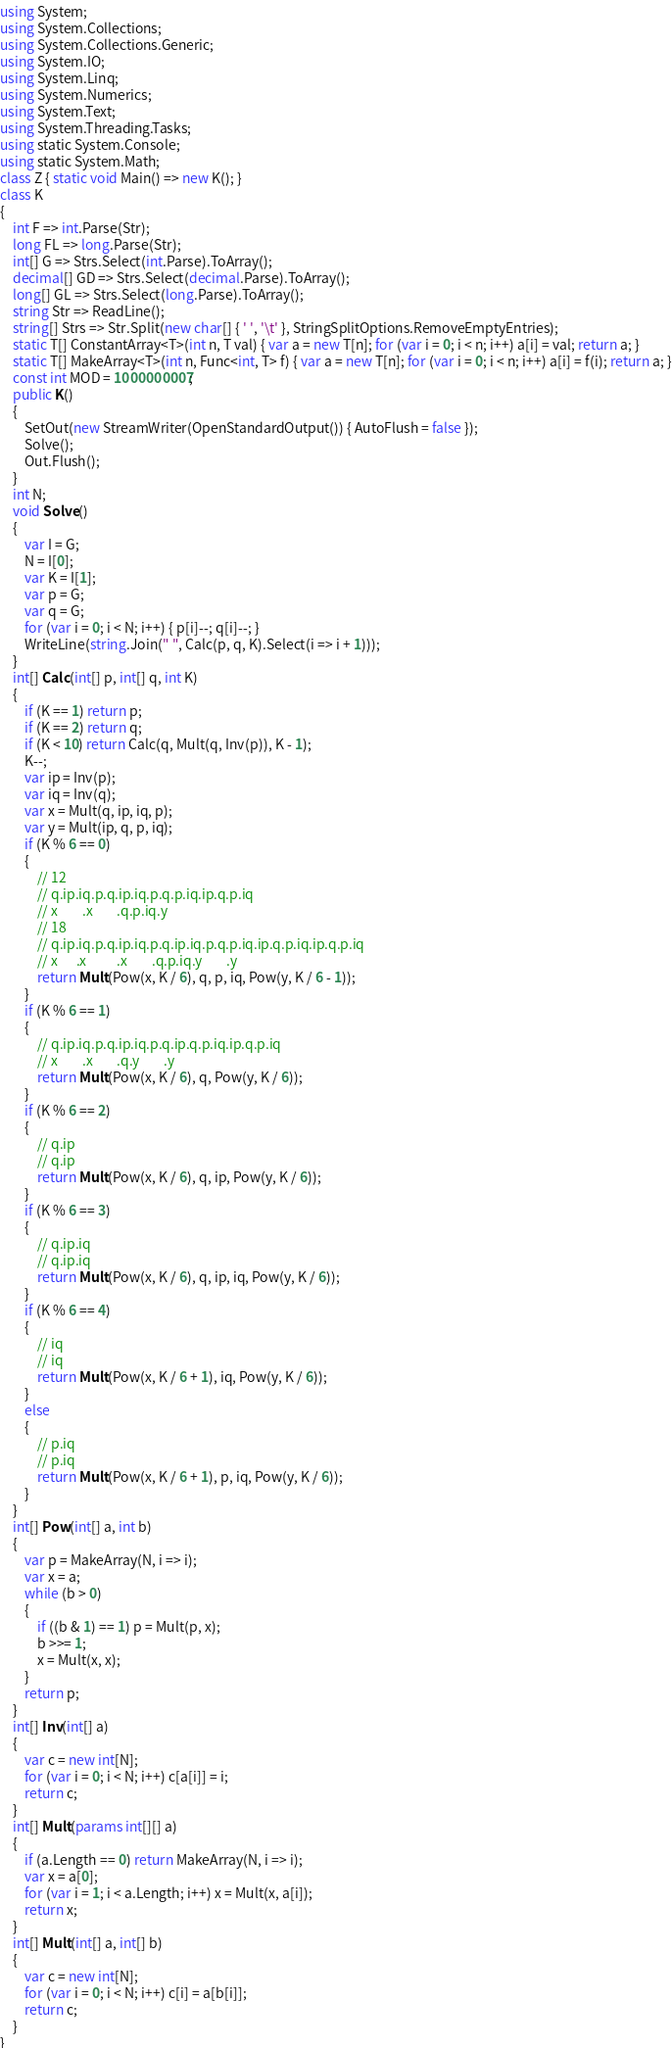<code> <loc_0><loc_0><loc_500><loc_500><_C#_>using System;
using System.Collections;
using System.Collections.Generic;
using System.IO;
using System.Linq;
using System.Numerics;
using System.Text;
using System.Threading.Tasks;
using static System.Console;
using static System.Math;
class Z { static void Main() => new K(); }
class K
{
	int F => int.Parse(Str);
	long FL => long.Parse(Str);
	int[] G => Strs.Select(int.Parse).ToArray();
	decimal[] GD => Strs.Select(decimal.Parse).ToArray();
	long[] GL => Strs.Select(long.Parse).ToArray();
	string Str => ReadLine();
	string[] Strs => Str.Split(new char[] { ' ', '\t' }, StringSplitOptions.RemoveEmptyEntries);
	static T[] ConstantArray<T>(int n, T val) { var a = new T[n]; for (var i = 0; i < n; i++) a[i] = val; return a; }
	static T[] MakeArray<T>(int n, Func<int, T> f) { var a = new T[n]; for (var i = 0; i < n; i++) a[i] = f(i); return a; }
	const int MOD = 1000000007;
	public K()
	{
		SetOut(new StreamWriter(OpenStandardOutput()) { AutoFlush = false });
		Solve();
		Out.Flush();
	}
	int N;
	void Solve()
	{
		var I = G;
		N = I[0];
		var K = I[1];
		var p = G;
		var q = G;
		for (var i = 0; i < N; i++) { p[i]--; q[i]--; }
		WriteLine(string.Join(" ", Calc(p, q, K).Select(i => i + 1)));
	}
	int[] Calc(int[] p, int[] q, int K)
	{
		if (K == 1) return p;
		if (K == 2) return q;
		if (K < 10) return Calc(q, Mult(q, Inv(p)), K - 1);
		K--;
		var ip = Inv(p);
		var iq = Inv(q);
		var x = Mult(q, ip, iq, p);
		var y = Mult(ip, q, p, iq);
		if (K % 6 == 0)
		{
			// 12
			// q.ip.iq.p.q.ip.iq.p.q.p.iq.ip.q.p.iq
			// x        .x        .q.p.iq.y
			// 18
			// q.ip.iq.p.q.ip.iq.p.q.ip.iq.p.q.p.iq.ip.q.p.iq.ip.q.p.iq
			// x      .x          .x        .q.p.iq.y        .y
			return Mult(Pow(x, K / 6), q, p, iq, Pow(y, K / 6 - 1));
		}
		if (K % 6 == 1)
		{
			// q.ip.iq.p.q.ip.iq.p.q.ip.q.p.iq.ip.q.p.iq
			// x        .x        .q.y        .y
			return Mult(Pow(x, K / 6), q, Pow(y, K / 6));
		}
		if (K % 6 == 2)
		{
			// q.ip
			// q.ip
			return Mult(Pow(x, K / 6), q, ip, Pow(y, K / 6));
		}
		if (K % 6 == 3)
		{
			// q.ip.iq
			// q.ip.iq
			return Mult(Pow(x, K / 6), q, ip, iq, Pow(y, K / 6));
		}
		if (K % 6 == 4)
		{
			// iq
			// iq
			return Mult(Pow(x, K / 6 + 1), iq, Pow(y, K / 6));
		}
		else
		{
			// p.iq
			// p.iq
			return Mult(Pow(x, K / 6 + 1), p, iq, Pow(y, K / 6));
		}
	}
	int[] Pow(int[] a, int b)
	{
		var p = MakeArray(N, i => i);
		var x = a;
		while (b > 0)
		{
			if ((b & 1) == 1) p = Mult(p, x);
			b >>= 1;
			x = Mult(x, x);
		}
		return p;
	}
	int[] Inv(int[] a)
	{
		var c = new int[N];
		for (var i = 0; i < N; i++) c[a[i]] = i;
		return c;
	}
	int[] Mult(params int[][] a)
	{
		if (a.Length == 0) return MakeArray(N, i => i);
		var x = a[0];
		for (var i = 1; i < a.Length; i++) x = Mult(x, a[i]);
		return x;
	}
	int[] Mult(int[] a, int[] b)
	{
		var c = new int[N];
		for (var i = 0; i < N; i++) c[i] = a[b[i]];
		return c;
	}
}
</code> 